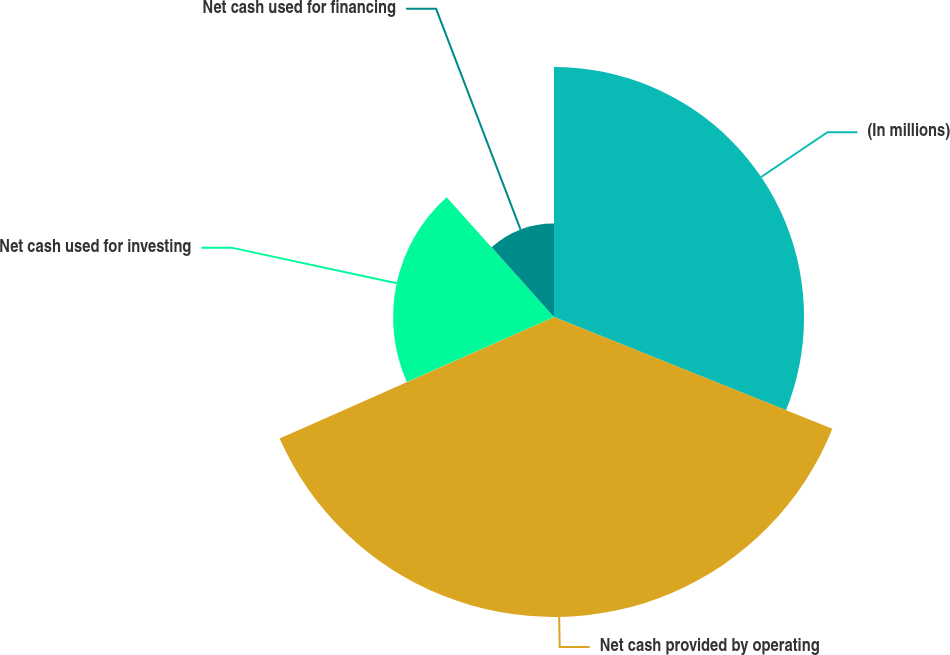Convert chart. <chart><loc_0><loc_0><loc_500><loc_500><pie_chart><fcel>(In millions)<fcel>Net cash provided by operating<fcel>Net cash used for investing<fcel>Net cash used for financing<nl><fcel>31.08%<fcel>37.29%<fcel>20.0%<fcel>11.63%<nl></chart> 